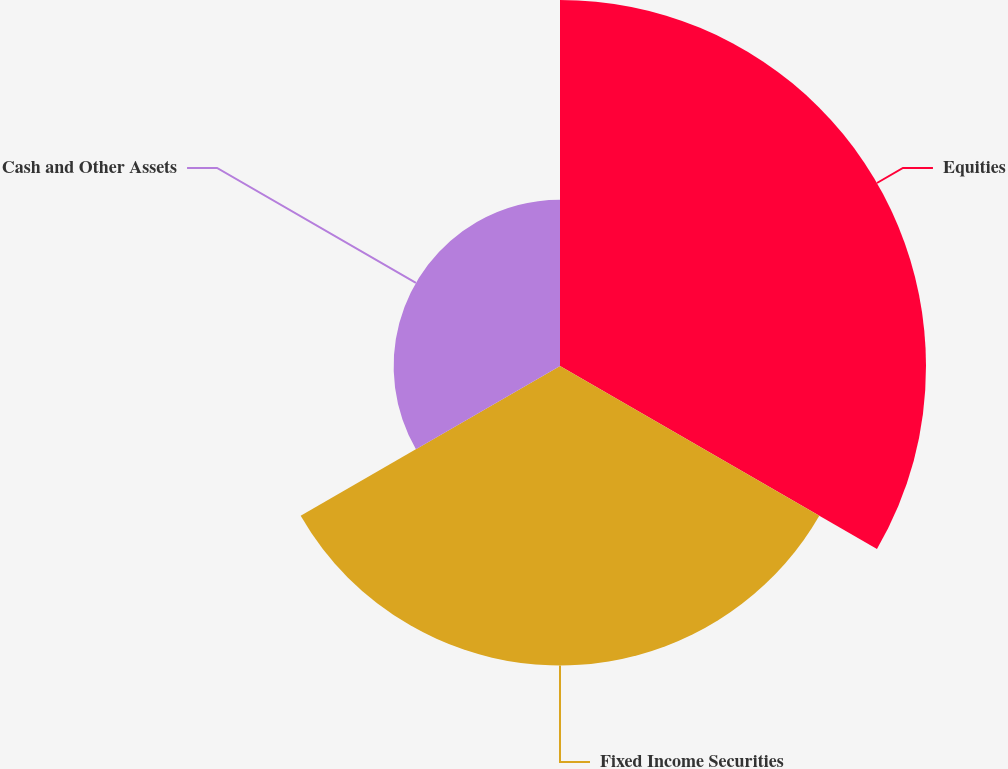Convert chart to OTSL. <chart><loc_0><loc_0><loc_500><loc_500><pie_chart><fcel>Equities<fcel>Fixed Income Securities<fcel>Cash and Other Assets<nl><fcel>44.0%<fcel>36.0%<fcel>20.0%<nl></chart> 